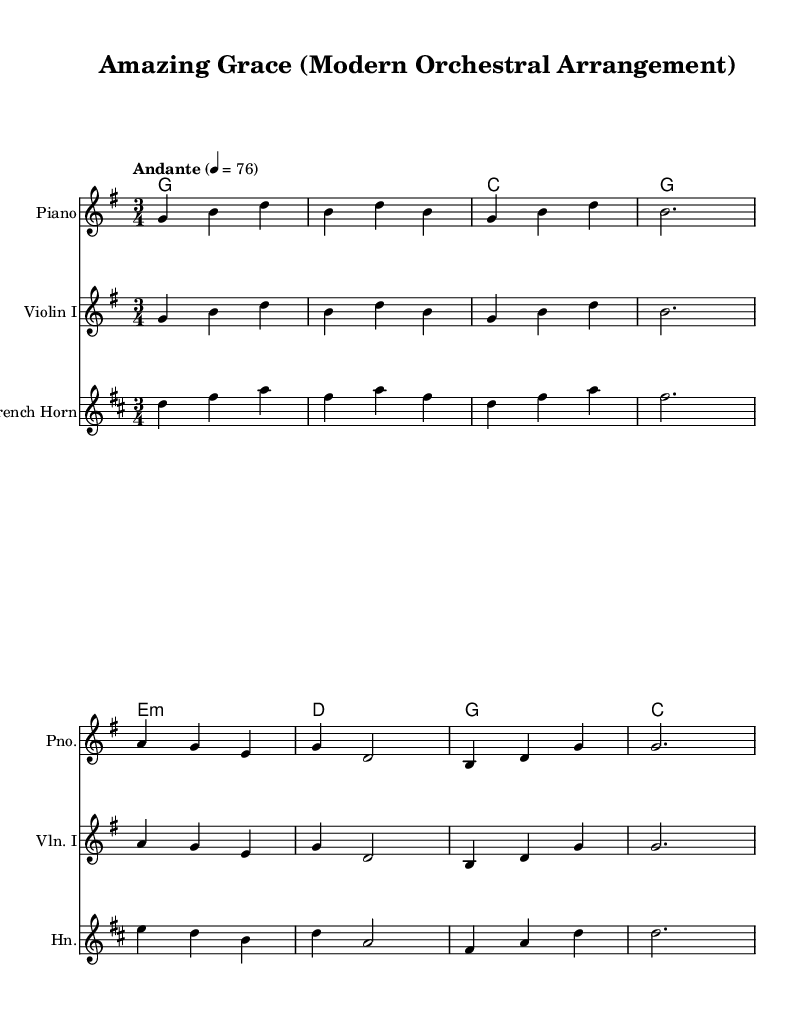What is the key signature of this music? The key signature is indicated at the beginning of the staff, showing one sharp (F#) which is characteristic of G major.
Answer: G major What is the time signature of this music? The time signature is displayed at the beginning of the score, showing that there are three beats in each measure.
Answer: 3/4 What is the tempo marking of this piece? The tempo marking appears above the staff, stating “Andante” with a metronome marking of 76, indicating a moderate pace.
Answer: Andante 4 = 76 How many measures are in the melody section? By counting the vertical bars (bar lines) in the melody, we can determine the number of measures. There are 8 measures in total.
Answer: 8 What instruments are included in this arrangement? The title and instrument names provided above each staff indicate the instruments used. This arrangement includes Piano, Violin I, and French Horn.
Answer: Piano, Violin I, French Horn What is the first chord in the harmony section? The harmony begins with the first chord represented as "g2." which indicates a G major chord in root position.
Answer: G major How is the melody transposed for the French Horn? The score explicitly shows a transposition indication for the French Horn as it is written a fifth higher, which is indicated by "transpose c g" in the code.
Answer: A fifth higher 